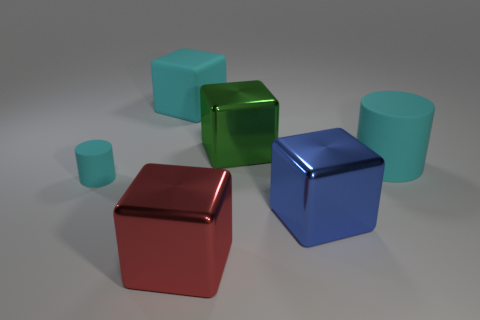Add 2 yellow shiny blocks. How many objects exist? 8 Subtract all big red shiny blocks. How many blocks are left? 3 Subtract all blue cubes. How many cubes are left? 3 Subtract all cubes. How many objects are left? 2 Subtract all blue spheres. How many purple blocks are left? 0 Subtract all small purple metal things. Subtract all large green cubes. How many objects are left? 5 Add 1 big rubber blocks. How many big rubber blocks are left? 2 Add 4 blue objects. How many blue objects exist? 5 Subtract 0 blue spheres. How many objects are left? 6 Subtract 2 cylinders. How many cylinders are left? 0 